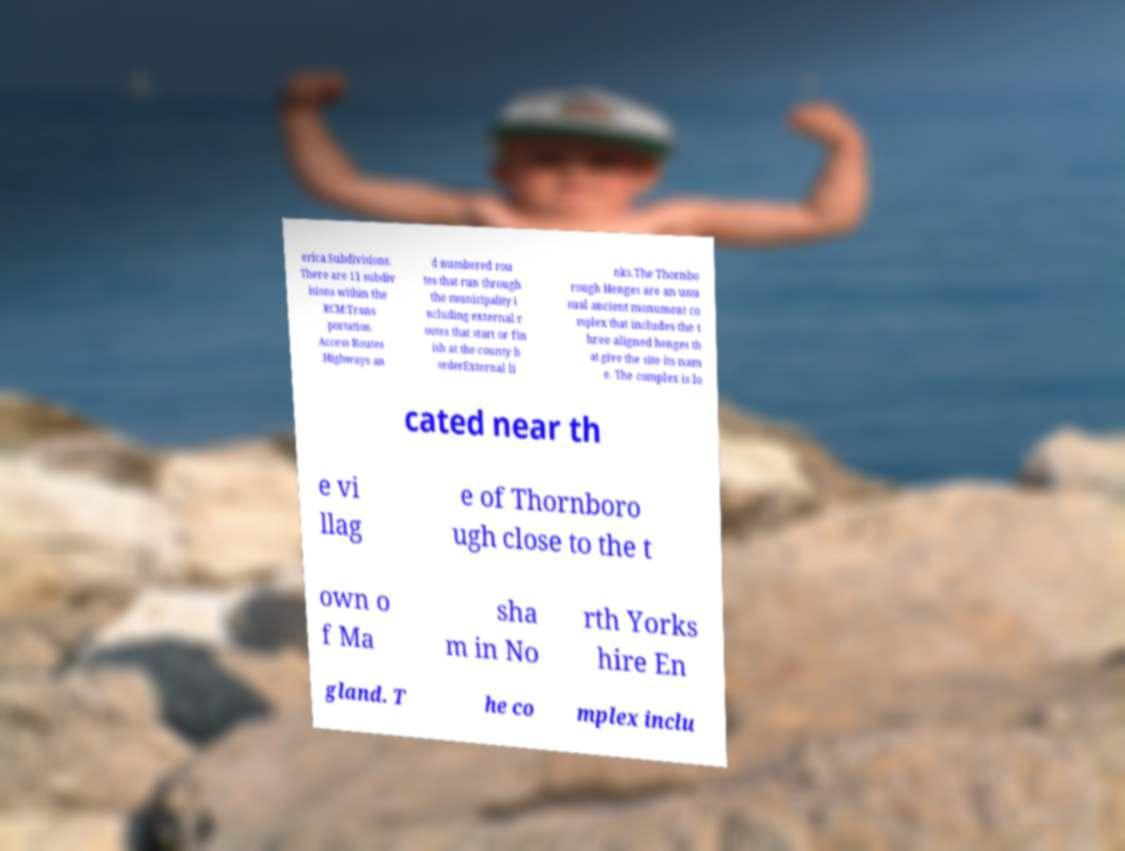What messages or text are displayed in this image? I need them in a readable, typed format. erica.Subdivisions. There are 11 subdiv isions within the RCM:Trans portation. Access Routes .Highways an d numbered rou tes that run through the municipality i ncluding external r outes that start or fin ish at the county b orderExternal li nks.The Thornbo rough Henges are an unu sual ancient monument co mplex that includes the t hree aligned henges th at give the site its nam e. The complex is lo cated near th e vi llag e of Thornboro ugh close to the t own o f Ma sha m in No rth Yorks hire En gland. T he co mplex inclu 